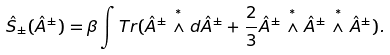Convert formula to latex. <formula><loc_0><loc_0><loc_500><loc_500>\hat { S } _ { \pm } ( \hat { A } ^ { \pm } ) = \beta \int T r ( \hat { A } ^ { \pm } \stackrel { ^ { * } } { \wedge } d \hat { A } ^ { \pm } + \frac { 2 } { 3 } \hat { A } ^ { \pm } \stackrel { ^ { * } } { \wedge } \hat { A } ^ { \pm } \stackrel { ^ { * } } { \wedge } \hat { A } ^ { \pm } ) .</formula> 